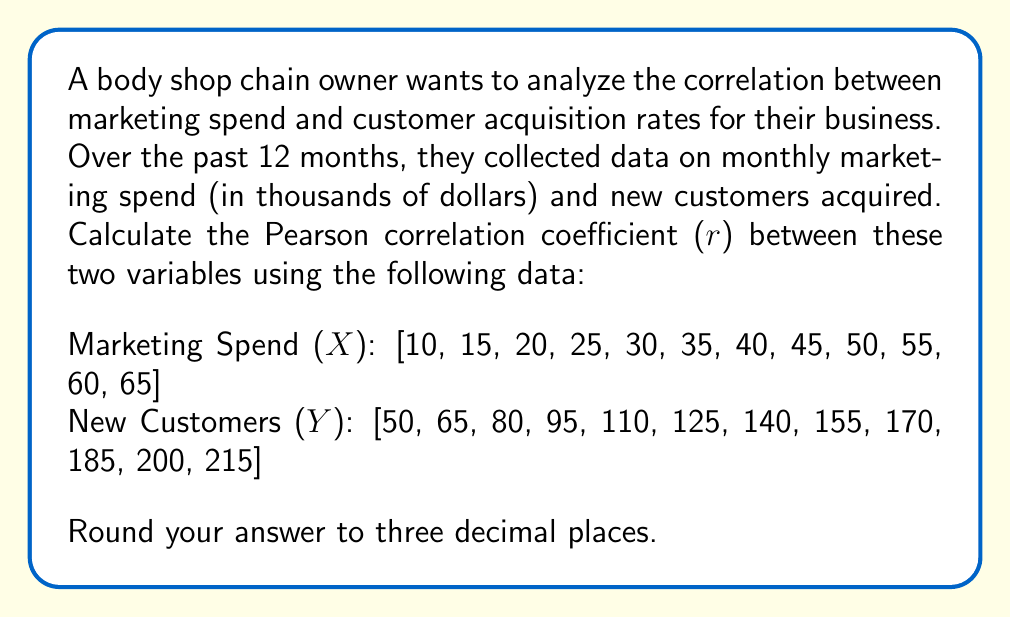Provide a solution to this math problem. To calculate the Pearson correlation coefficient (r), we'll use the formula:

$$ r = \frac{n\sum xy - \sum x \sum y}{\sqrt{[n\sum x^2 - (\sum x)^2][n\sum y^2 - (\sum y)^2]}} $$

Where:
n = number of pairs of data
x = marketing spend
y = new customers

Step 1: Calculate the required sums:
n = 12
$\sum x = 450$
$\sum y = 1590$
$\sum xy = 63,850$
$\sum x^2 = 18,750$
$\sum y^2 = 225,050$

Step 2: Calculate $(\sum x)^2$ and $(\sum y)^2$:
$(\sum x)^2 = 450^2 = 202,500$
$(\sum y)^2 = 1590^2 = 2,528,100$

Step 3: Substitute values into the correlation coefficient formula:

$$ r = \frac{12(63,850) - (450)(1590)}{\sqrt{[12(18,750) - 202,500][12(225,050) - 2,528,100]}} $$

Step 4: Simplify the numerator and denominator:

$$ r = \frac{766,200 - 715,500}{\sqrt{(225,000 - 202,500)(2,700,600 - 2,528,100)}} $$

$$ r = \frac{50,700}{\sqrt{(22,500)(172,500)}} $$

Step 5: Calculate the final result:

$$ r = \frac{50,700}{\sqrt{3,881,250,000}} = \frac{50,700}{62,300} \approx 0.814 $$
Answer: 0.814 